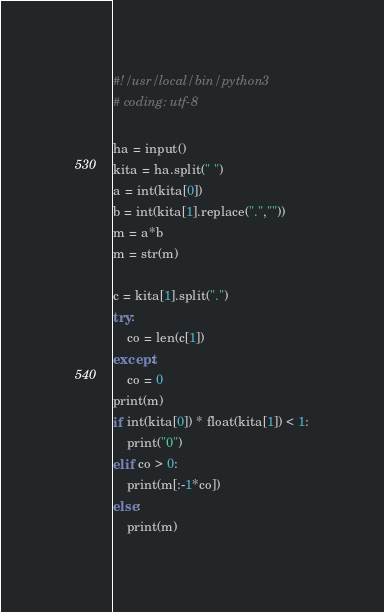Convert code to text. <code><loc_0><loc_0><loc_500><loc_500><_Python_>#!/usr/local/bin/python3
# coding: utf-8

ha = input()
kita = ha.split(" ")
a = int(kita[0])
b = int(kita[1].replace(".",""))
m = a*b
m = str(m)

c = kita[1].split(".")
try:
    co = len(c[1])
except:
    co = 0
print(m)
if int(kita[0]) * float(kita[1]) < 1:
    print("0")
elif co > 0:
    print(m[:-1*co])
else:
    print(m)</code> 